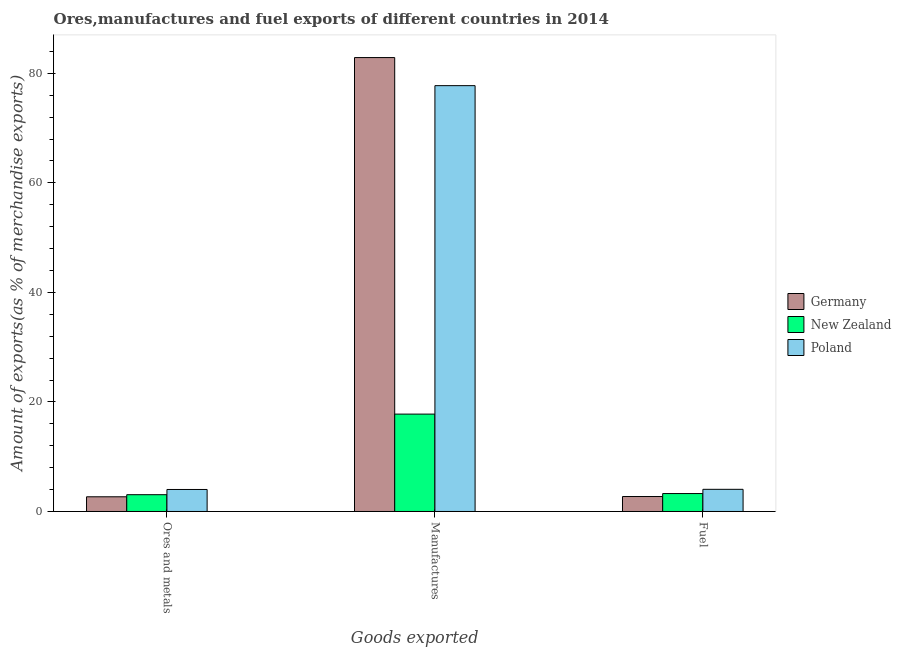How many different coloured bars are there?
Provide a short and direct response. 3. Are the number of bars per tick equal to the number of legend labels?
Make the answer very short. Yes. How many bars are there on the 1st tick from the left?
Your answer should be compact. 3. How many bars are there on the 2nd tick from the right?
Make the answer very short. 3. What is the label of the 3rd group of bars from the left?
Ensure brevity in your answer.  Fuel. What is the percentage of ores and metals exports in Poland?
Offer a terse response. 4.02. Across all countries, what is the maximum percentage of ores and metals exports?
Your answer should be very brief. 4.02. Across all countries, what is the minimum percentage of ores and metals exports?
Make the answer very short. 2.68. In which country was the percentage of fuel exports minimum?
Provide a short and direct response. Germany. What is the total percentage of fuel exports in the graph?
Offer a very short reply. 10.05. What is the difference between the percentage of ores and metals exports in Poland and that in Germany?
Provide a short and direct response. 1.33. What is the difference between the percentage of manufactures exports in Germany and the percentage of ores and metals exports in New Zealand?
Your answer should be very brief. 79.81. What is the average percentage of fuel exports per country?
Your response must be concise. 3.35. What is the difference between the percentage of fuel exports and percentage of manufactures exports in Poland?
Make the answer very short. -73.7. What is the ratio of the percentage of fuel exports in Poland to that in New Zealand?
Keep it short and to the point. 1.24. Is the difference between the percentage of manufactures exports in Germany and New Zealand greater than the difference between the percentage of fuel exports in Germany and New Zealand?
Offer a terse response. Yes. What is the difference between the highest and the second highest percentage of manufactures exports?
Your answer should be very brief. 5.13. What is the difference between the highest and the lowest percentage of manufactures exports?
Provide a short and direct response. 65.09. In how many countries, is the percentage of ores and metals exports greater than the average percentage of ores and metals exports taken over all countries?
Provide a succinct answer. 1. What does the 1st bar from the right in Manufactures represents?
Your answer should be compact. Poland. Is it the case that in every country, the sum of the percentage of ores and metals exports and percentage of manufactures exports is greater than the percentage of fuel exports?
Ensure brevity in your answer.  Yes. How many bars are there?
Give a very brief answer. 9. Are all the bars in the graph horizontal?
Your answer should be very brief. No. How many countries are there in the graph?
Your answer should be very brief. 3. Does the graph contain any zero values?
Your response must be concise. No. How many legend labels are there?
Your answer should be very brief. 3. What is the title of the graph?
Your response must be concise. Ores,manufactures and fuel exports of different countries in 2014. Does "South Africa" appear as one of the legend labels in the graph?
Make the answer very short. No. What is the label or title of the X-axis?
Offer a very short reply. Goods exported. What is the label or title of the Y-axis?
Provide a succinct answer. Amount of exports(as % of merchandise exports). What is the Amount of exports(as % of merchandise exports) of Germany in Ores and metals?
Provide a succinct answer. 2.68. What is the Amount of exports(as % of merchandise exports) in New Zealand in Ores and metals?
Your answer should be very brief. 3.07. What is the Amount of exports(as % of merchandise exports) of Poland in Ores and metals?
Give a very brief answer. 4.02. What is the Amount of exports(as % of merchandise exports) of Germany in Manufactures?
Provide a succinct answer. 82.87. What is the Amount of exports(as % of merchandise exports) in New Zealand in Manufactures?
Make the answer very short. 17.78. What is the Amount of exports(as % of merchandise exports) in Poland in Manufactures?
Offer a terse response. 77.75. What is the Amount of exports(as % of merchandise exports) in Germany in Fuel?
Your answer should be compact. 2.73. What is the Amount of exports(as % of merchandise exports) of New Zealand in Fuel?
Your answer should be compact. 3.27. What is the Amount of exports(as % of merchandise exports) of Poland in Fuel?
Make the answer very short. 4.05. Across all Goods exported, what is the maximum Amount of exports(as % of merchandise exports) in Germany?
Provide a short and direct response. 82.87. Across all Goods exported, what is the maximum Amount of exports(as % of merchandise exports) in New Zealand?
Provide a succinct answer. 17.78. Across all Goods exported, what is the maximum Amount of exports(as % of merchandise exports) in Poland?
Provide a succinct answer. 77.75. Across all Goods exported, what is the minimum Amount of exports(as % of merchandise exports) of Germany?
Offer a very short reply. 2.68. Across all Goods exported, what is the minimum Amount of exports(as % of merchandise exports) in New Zealand?
Keep it short and to the point. 3.07. Across all Goods exported, what is the minimum Amount of exports(as % of merchandise exports) of Poland?
Offer a very short reply. 4.02. What is the total Amount of exports(as % of merchandise exports) of Germany in the graph?
Keep it short and to the point. 88.29. What is the total Amount of exports(as % of merchandise exports) in New Zealand in the graph?
Your answer should be compact. 24.12. What is the total Amount of exports(as % of merchandise exports) of Poland in the graph?
Keep it short and to the point. 85.81. What is the difference between the Amount of exports(as % of merchandise exports) in Germany in Ores and metals and that in Manufactures?
Give a very brief answer. -80.19. What is the difference between the Amount of exports(as % of merchandise exports) of New Zealand in Ores and metals and that in Manufactures?
Keep it short and to the point. -14.72. What is the difference between the Amount of exports(as % of merchandise exports) of Poland in Ores and metals and that in Manufactures?
Your answer should be very brief. -73.73. What is the difference between the Amount of exports(as % of merchandise exports) in Germany in Ores and metals and that in Fuel?
Provide a succinct answer. -0.05. What is the difference between the Amount of exports(as % of merchandise exports) of New Zealand in Ores and metals and that in Fuel?
Keep it short and to the point. -0.21. What is the difference between the Amount of exports(as % of merchandise exports) in Poland in Ores and metals and that in Fuel?
Make the answer very short. -0.03. What is the difference between the Amount of exports(as % of merchandise exports) of Germany in Manufactures and that in Fuel?
Make the answer very short. 80.14. What is the difference between the Amount of exports(as % of merchandise exports) of New Zealand in Manufactures and that in Fuel?
Make the answer very short. 14.51. What is the difference between the Amount of exports(as % of merchandise exports) of Poland in Manufactures and that in Fuel?
Provide a short and direct response. 73.7. What is the difference between the Amount of exports(as % of merchandise exports) of Germany in Ores and metals and the Amount of exports(as % of merchandise exports) of New Zealand in Manufactures?
Provide a succinct answer. -15.1. What is the difference between the Amount of exports(as % of merchandise exports) of Germany in Ores and metals and the Amount of exports(as % of merchandise exports) of Poland in Manufactures?
Provide a succinct answer. -75.06. What is the difference between the Amount of exports(as % of merchandise exports) of New Zealand in Ores and metals and the Amount of exports(as % of merchandise exports) of Poland in Manufactures?
Your answer should be very brief. -74.68. What is the difference between the Amount of exports(as % of merchandise exports) in Germany in Ores and metals and the Amount of exports(as % of merchandise exports) in New Zealand in Fuel?
Your answer should be very brief. -0.59. What is the difference between the Amount of exports(as % of merchandise exports) of Germany in Ores and metals and the Amount of exports(as % of merchandise exports) of Poland in Fuel?
Ensure brevity in your answer.  -1.36. What is the difference between the Amount of exports(as % of merchandise exports) of New Zealand in Ores and metals and the Amount of exports(as % of merchandise exports) of Poland in Fuel?
Your response must be concise. -0.98. What is the difference between the Amount of exports(as % of merchandise exports) in Germany in Manufactures and the Amount of exports(as % of merchandise exports) in New Zealand in Fuel?
Provide a succinct answer. 79.6. What is the difference between the Amount of exports(as % of merchandise exports) of Germany in Manufactures and the Amount of exports(as % of merchandise exports) of Poland in Fuel?
Provide a succinct answer. 78.83. What is the difference between the Amount of exports(as % of merchandise exports) in New Zealand in Manufactures and the Amount of exports(as % of merchandise exports) in Poland in Fuel?
Your answer should be very brief. 13.73. What is the average Amount of exports(as % of merchandise exports) of Germany per Goods exported?
Provide a succinct answer. 29.43. What is the average Amount of exports(as % of merchandise exports) of New Zealand per Goods exported?
Provide a succinct answer. 8.04. What is the average Amount of exports(as % of merchandise exports) of Poland per Goods exported?
Your response must be concise. 28.6. What is the difference between the Amount of exports(as % of merchandise exports) in Germany and Amount of exports(as % of merchandise exports) in New Zealand in Ores and metals?
Keep it short and to the point. -0.38. What is the difference between the Amount of exports(as % of merchandise exports) of Germany and Amount of exports(as % of merchandise exports) of Poland in Ores and metals?
Give a very brief answer. -1.33. What is the difference between the Amount of exports(as % of merchandise exports) of New Zealand and Amount of exports(as % of merchandise exports) of Poland in Ores and metals?
Your response must be concise. -0.95. What is the difference between the Amount of exports(as % of merchandise exports) of Germany and Amount of exports(as % of merchandise exports) of New Zealand in Manufactures?
Give a very brief answer. 65.09. What is the difference between the Amount of exports(as % of merchandise exports) in Germany and Amount of exports(as % of merchandise exports) in Poland in Manufactures?
Keep it short and to the point. 5.13. What is the difference between the Amount of exports(as % of merchandise exports) in New Zealand and Amount of exports(as % of merchandise exports) in Poland in Manufactures?
Keep it short and to the point. -59.97. What is the difference between the Amount of exports(as % of merchandise exports) of Germany and Amount of exports(as % of merchandise exports) of New Zealand in Fuel?
Your answer should be very brief. -0.54. What is the difference between the Amount of exports(as % of merchandise exports) of Germany and Amount of exports(as % of merchandise exports) of Poland in Fuel?
Ensure brevity in your answer.  -1.31. What is the difference between the Amount of exports(as % of merchandise exports) of New Zealand and Amount of exports(as % of merchandise exports) of Poland in Fuel?
Your answer should be compact. -0.77. What is the ratio of the Amount of exports(as % of merchandise exports) of Germany in Ores and metals to that in Manufactures?
Provide a succinct answer. 0.03. What is the ratio of the Amount of exports(as % of merchandise exports) in New Zealand in Ores and metals to that in Manufactures?
Provide a succinct answer. 0.17. What is the ratio of the Amount of exports(as % of merchandise exports) in Poland in Ores and metals to that in Manufactures?
Give a very brief answer. 0.05. What is the ratio of the Amount of exports(as % of merchandise exports) in Germany in Ores and metals to that in Fuel?
Your answer should be compact. 0.98. What is the ratio of the Amount of exports(as % of merchandise exports) of New Zealand in Ores and metals to that in Fuel?
Provide a succinct answer. 0.94. What is the ratio of the Amount of exports(as % of merchandise exports) in Poland in Ores and metals to that in Fuel?
Ensure brevity in your answer.  0.99. What is the ratio of the Amount of exports(as % of merchandise exports) of Germany in Manufactures to that in Fuel?
Provide a short and direct response. 30.33. What is the ratio of the Amount of exports(as % of merchandise exports) in New Zealand in Manufactures to that in Fuel?
Your response must be concise. 5.43. What is the ratio of the Amount of exports(as % of merchandise exports) in Poland in Manufactures to that in Fuel?
Your answer should be very brief. 19.21. What is the difference between the highest and the second highest Amount of exports(as % of merchandise exports) of Germany?
Your response must be concise. 80.14. What is the difference between the highest and the second highest Amount of exports(as % of merchandise exports) of New Zealand?
Offer a very short reply. 14.51. What is the difference between the highest and the second highest Amount of exports(as % of merchandise exports) of Poland?
Give a very brief answer. 73.7. What is the difference between the highest and the lowest Amount of exports(as % of merchandise exports) of Germany?
Ensure brevity in your answer.  80.19. What is the difference between the highest and the lowest Amount of exports(as % of merchandise exports) of New Zealand?
Ensure brevity in your answer.  14.72. What is the difference between the highest and the lowest Amount of exports(as % of merchandise exports) in Poland?
Your answer should be compact. 73.73. 